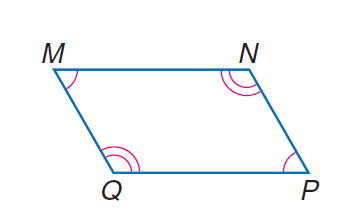Answer the mathemtical geometry problem and directly provide the correct option letter.
Question: parallelogram M N P Q with m \angle M = 10 x and m \angle N = 20 x, find \angle P.
Choices: A: 30 B: 45 C: 60 D: 120 C 